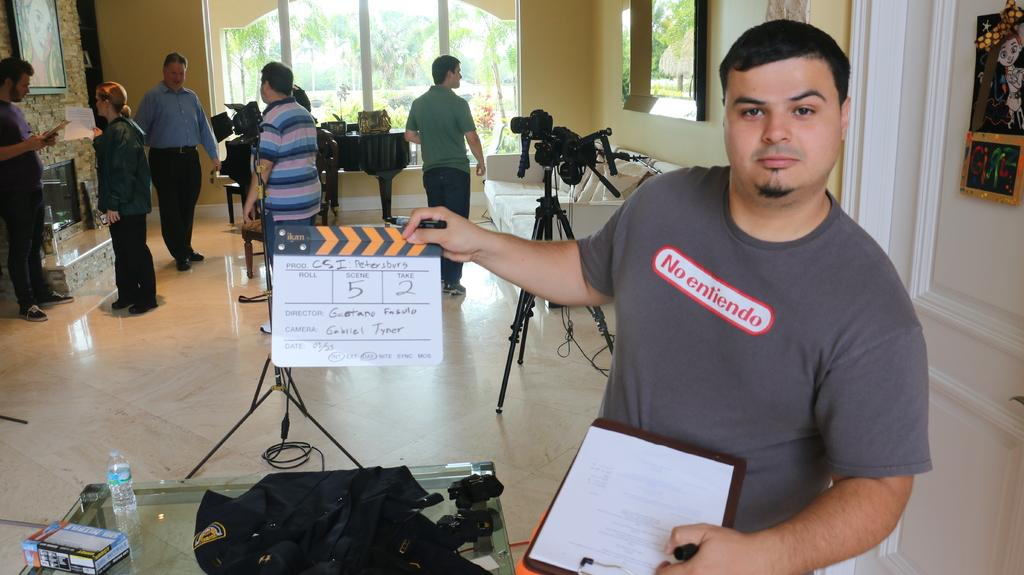What are the people in the image doing? The persons standing on the floor in the image are likely engaged in some activity, but the specifics are not clear from the facts provided. What can be seen through the windows in the image? The facts do not specify what can be seen through the windows, so we cannot answer this question definitively. What is the camera used for in the image? The camera is likely being used for photography or videography, but the specific purpose is not clear from the facts provided. What is the tripod supporting in the image? The tripod is likely supporting the camera, but the specifics are not clear from the facts provided. What are the papers used for in the image? The purpose of the papers in the image is not clear from the facts provided. What is the plank used for in the image? The purpose of the plank in the image is not clear from the facts provided. What are the cables connected to in the image? The facts do not specify what the cables are connected to, so we cannot answer this question definitively. What is the disposal bottle used for in the image? The purpose of the disposal bottle in the image is not clear from the facts provided. What is the table used for in the image? The table is likely being used as a surface for various items, but the specifics are not clear from the facts provided. What are the books used for in the image? The purpose of the books in the image is not clear from the facts provided. What is the mantelpiece used for in the image? The purpose of the mantelpiece in the image is not clear from the facts provided. What value does the question have in the image? There is no specific question present in the image, so we cannot determine its value. What type of apparatus is used for asking questions in the image? There is no apparatus present in the image that is specifically designed for asking questions. 